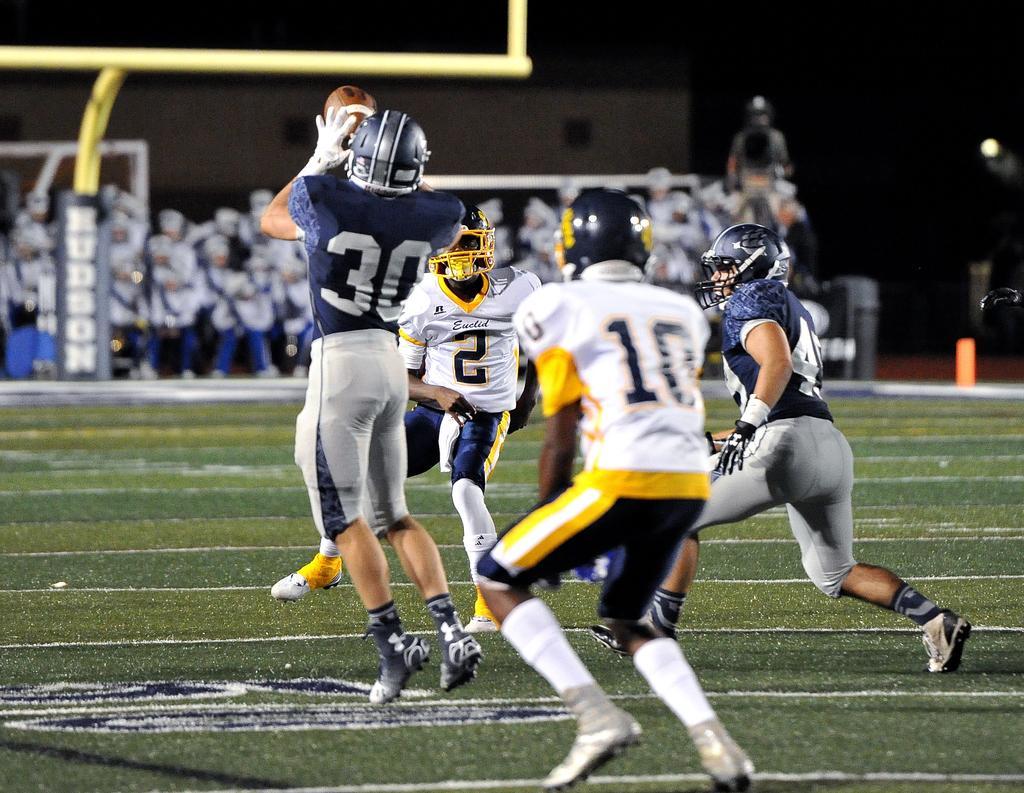Could you give a brief overview of what you see in this image? On the football ground there are four players running. Two players are wearing white t-shirt and other two are wearing blue t-shirt. All the four are running on the ground and wearing helmets on their head. A man with blue t-shirt in the left side is holding a ball in his hand. In the background there are group of people standing and watching. 